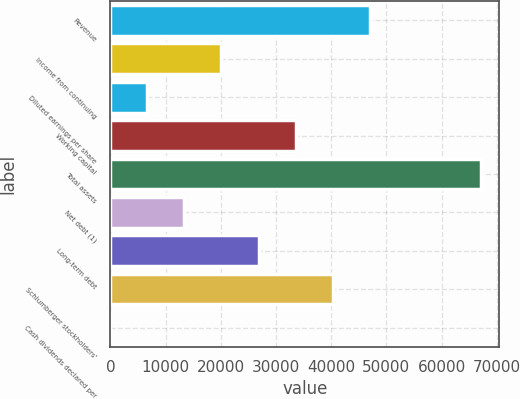<chart> <loc_0><loc_0><loc_500><loc_500><bar_chart><fcel>Revenue<fcel>Income from continuing<fcel>Diluted earnings per share<fcel>Working capital<fcel>Total assets<fcel>Net debt (1)<fcel>Long-term debt<fcel>Schlumberger stockholders'<fcel>Cash dividends declared per<nl><fcel>46970.4<fcel>20130.9<fcel>6711.12<fcel>33550.6<fcel>67100<fcel>13421<fcel>26840.7<fcel>40260.5<fcel>1.25<nl></chart> 